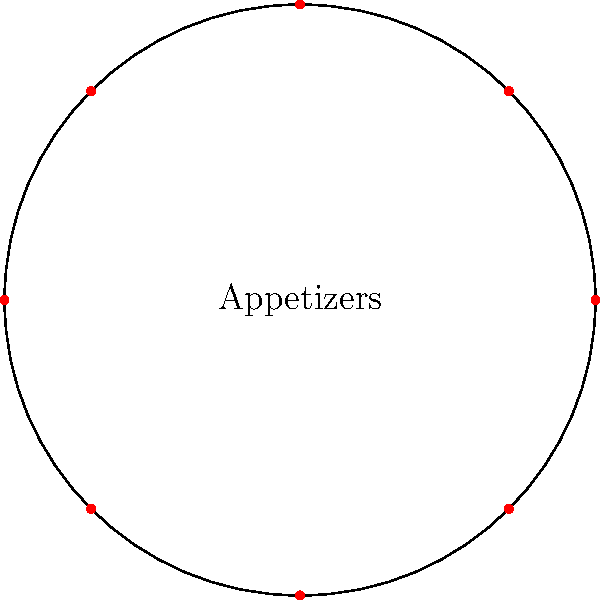A circular serving platter is divided into 8 equal sections, with each section containing a different appetizer. If the platter has a radius of 12 inches, what is the polar coordinate representation $(r,\theta)$ of the position of the third appetizer, assuming the first appetizer is placed at $\theta=0$? To solve this problem, we need to follow these steps:

1) First, we need to understand that the platter is divided into 8 equal sections. This means each section spans an angle of $\frac{360°}{8} = 45°$ or $\frac{\pi}{4}$ radians.

2) The third appetizer will be positioned at an angle of $2 * 45° = 90°$ or $\frac{\pi}{2}$ radians from the starting position.

3) The radius of the platter is given as 12 inches. In polar coordinates, the distance from the center (r) remains constant for all appetizers placed at the edge of the platter.

4) Therefore, the polar coordinate representation will be:
   $r = 12$ (the radius in inches)
   $\theta = \frac{\pi}{2}$ (the angle in radians)

5) The final representation in polar coordinates is $(12, \frac{\pi}{2})$.
Answer: $(12, \frac{\pi}{2})$ 